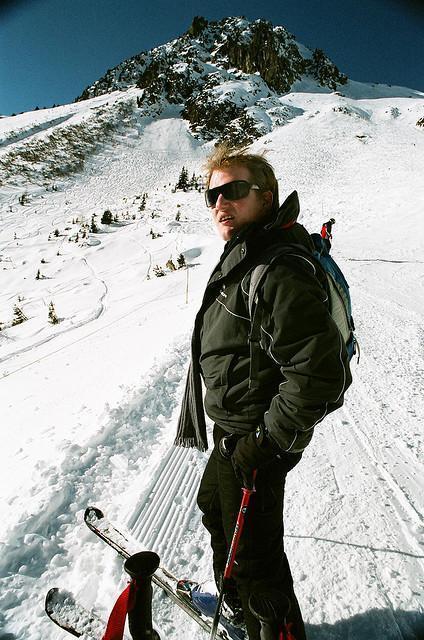What look does the man have on his face?
Indicate the correct response and explain using: 'Answer: answer
Rationale: rationale.'
Options: Sadness, disgust, love, joy. Answer: disgust.
Rationale: Their top lip is curled and mouth is open. they aren't smiling or crying. 